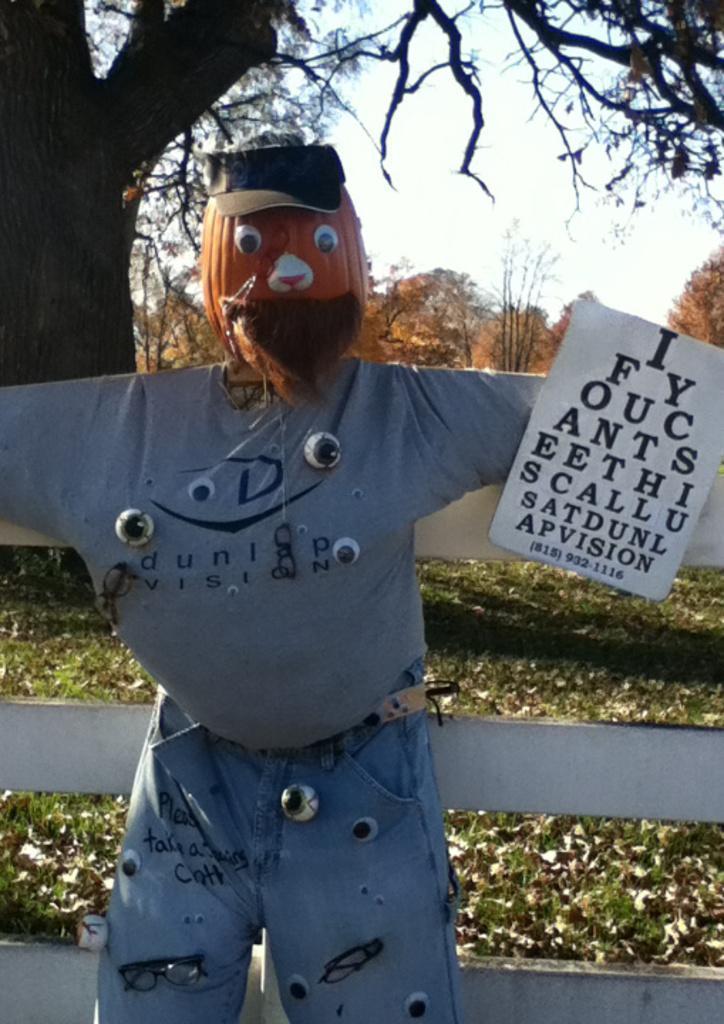Describe this image in one or two sentences. This looks like a scarecrow with the clothes. I think this is a board, which is attached to the scarecrow. This looks like a wooden fence. I can see the trees. I think these are the dried leaves, lying on the grass. 